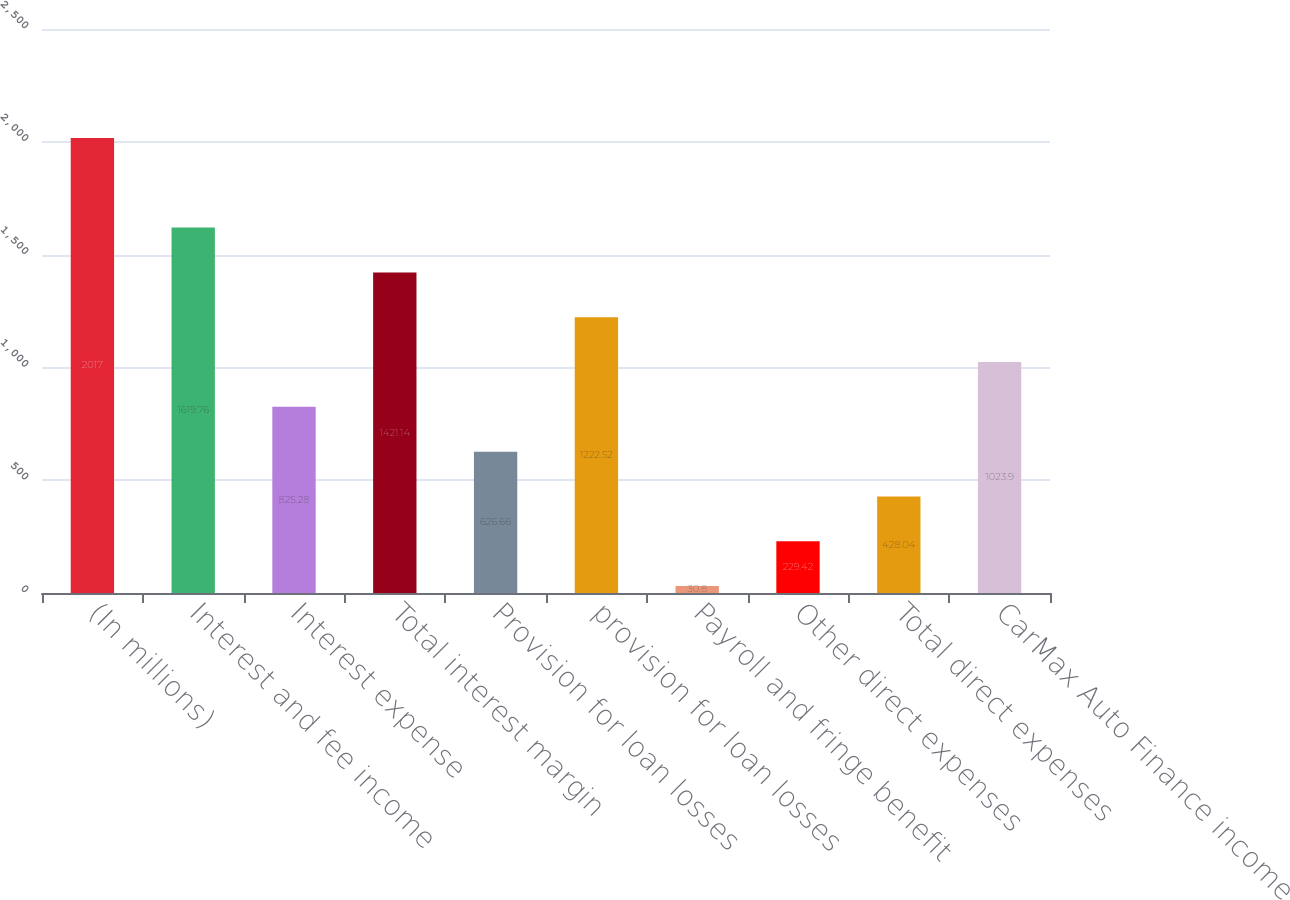Convert chart. <chart><loc_0><loc_0><loc_500><loc_500><bar_chart><fcel>(In millions)<fcel>Interest and fee income<fcel>Interest expense<fcel>Total interest margin<fcel>Provision for loan losses<fcel>provision for loan losses<fcel>Payroll and fringe benefit<fcel>Other direct expenses<fcel>Total direct expenses<fcel>CarMax Auto Finance income<nl><fcel>2017<fcel>1619.76<fcel>825.28<fcel>1421.14<fcel>626.66<fcel>1222.52<fcel>30.8<fcel>229.42<fcel>428.04<fcel>1023.9<nl></chart> 